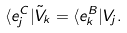Convert formula to latex. <formula><loc_0><loc_0><loc_500><loc_500>\langle e _ { j } ^ { C } | \tilde { V } _ { k } = \langle e _ { k } ^ { B } | V _ { j } .</formula> 